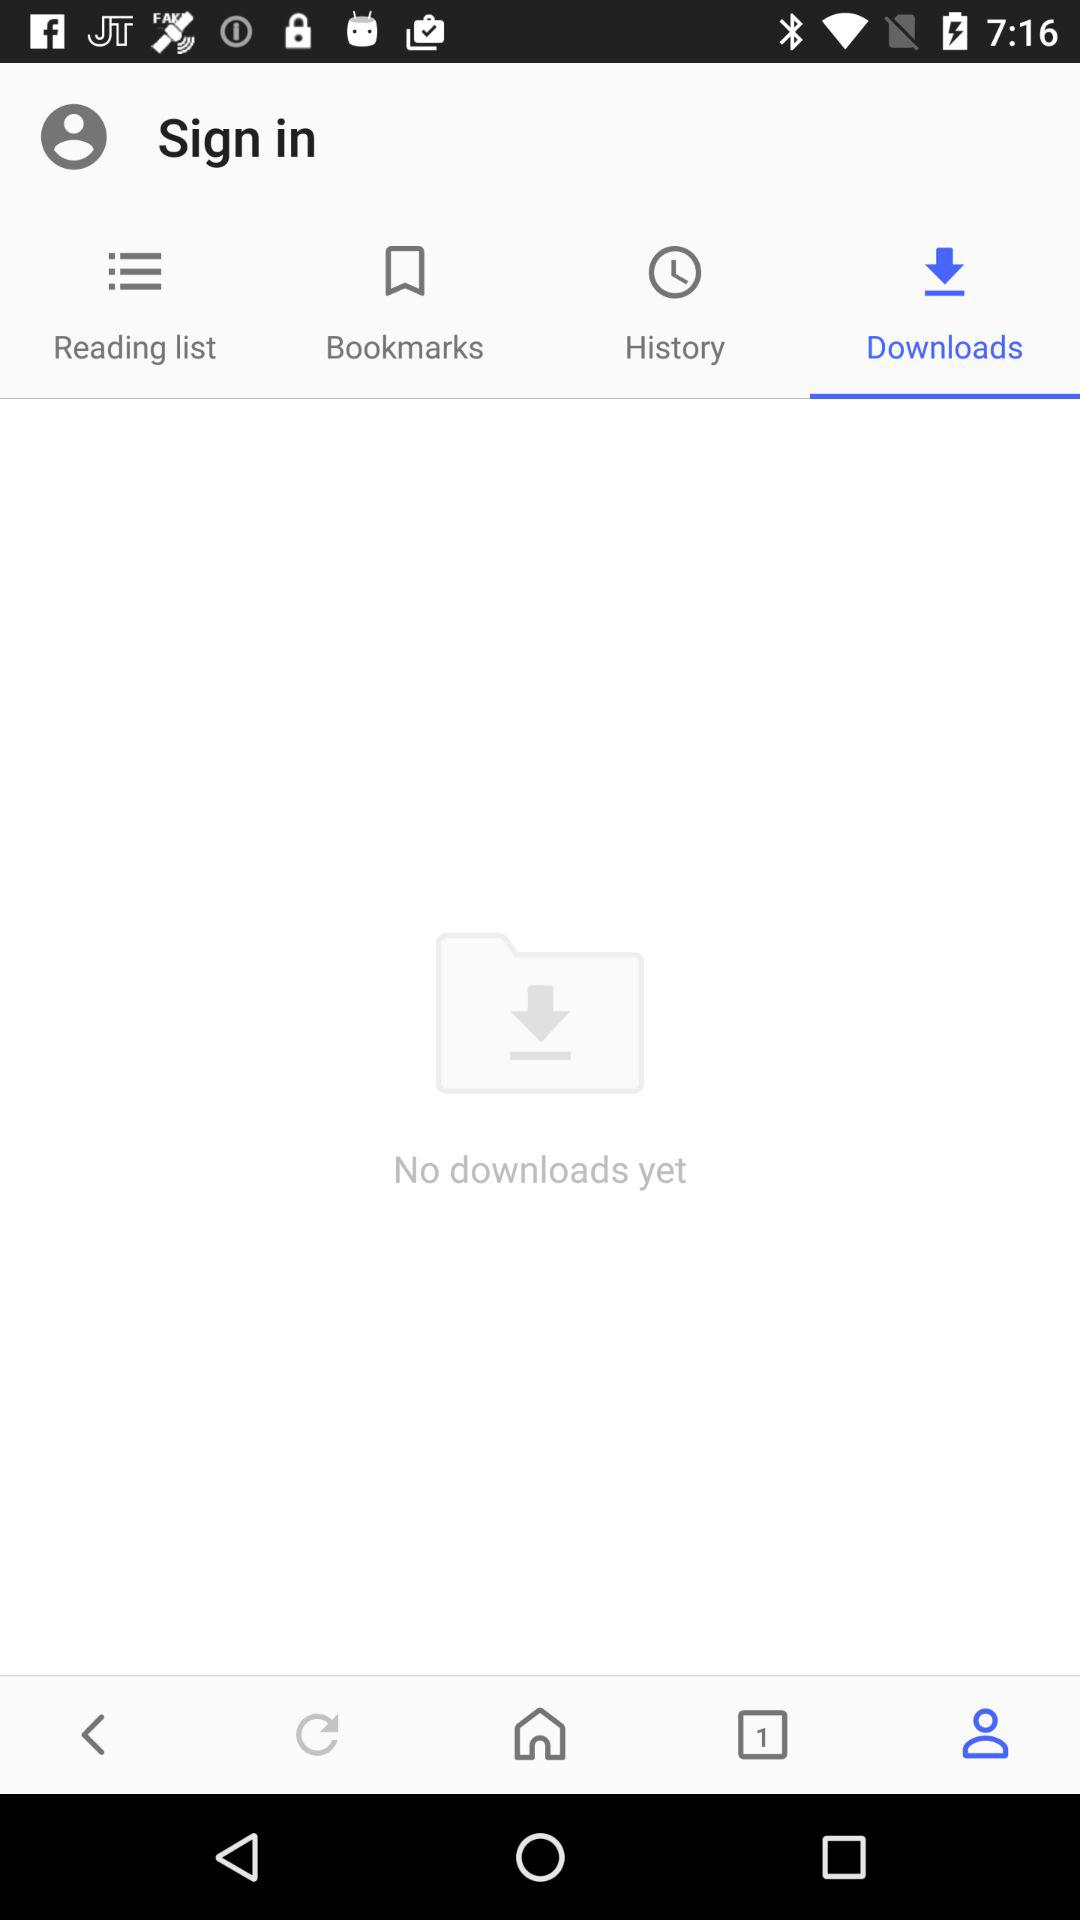How many downloads are there right now? Right now, there are no downloads. 